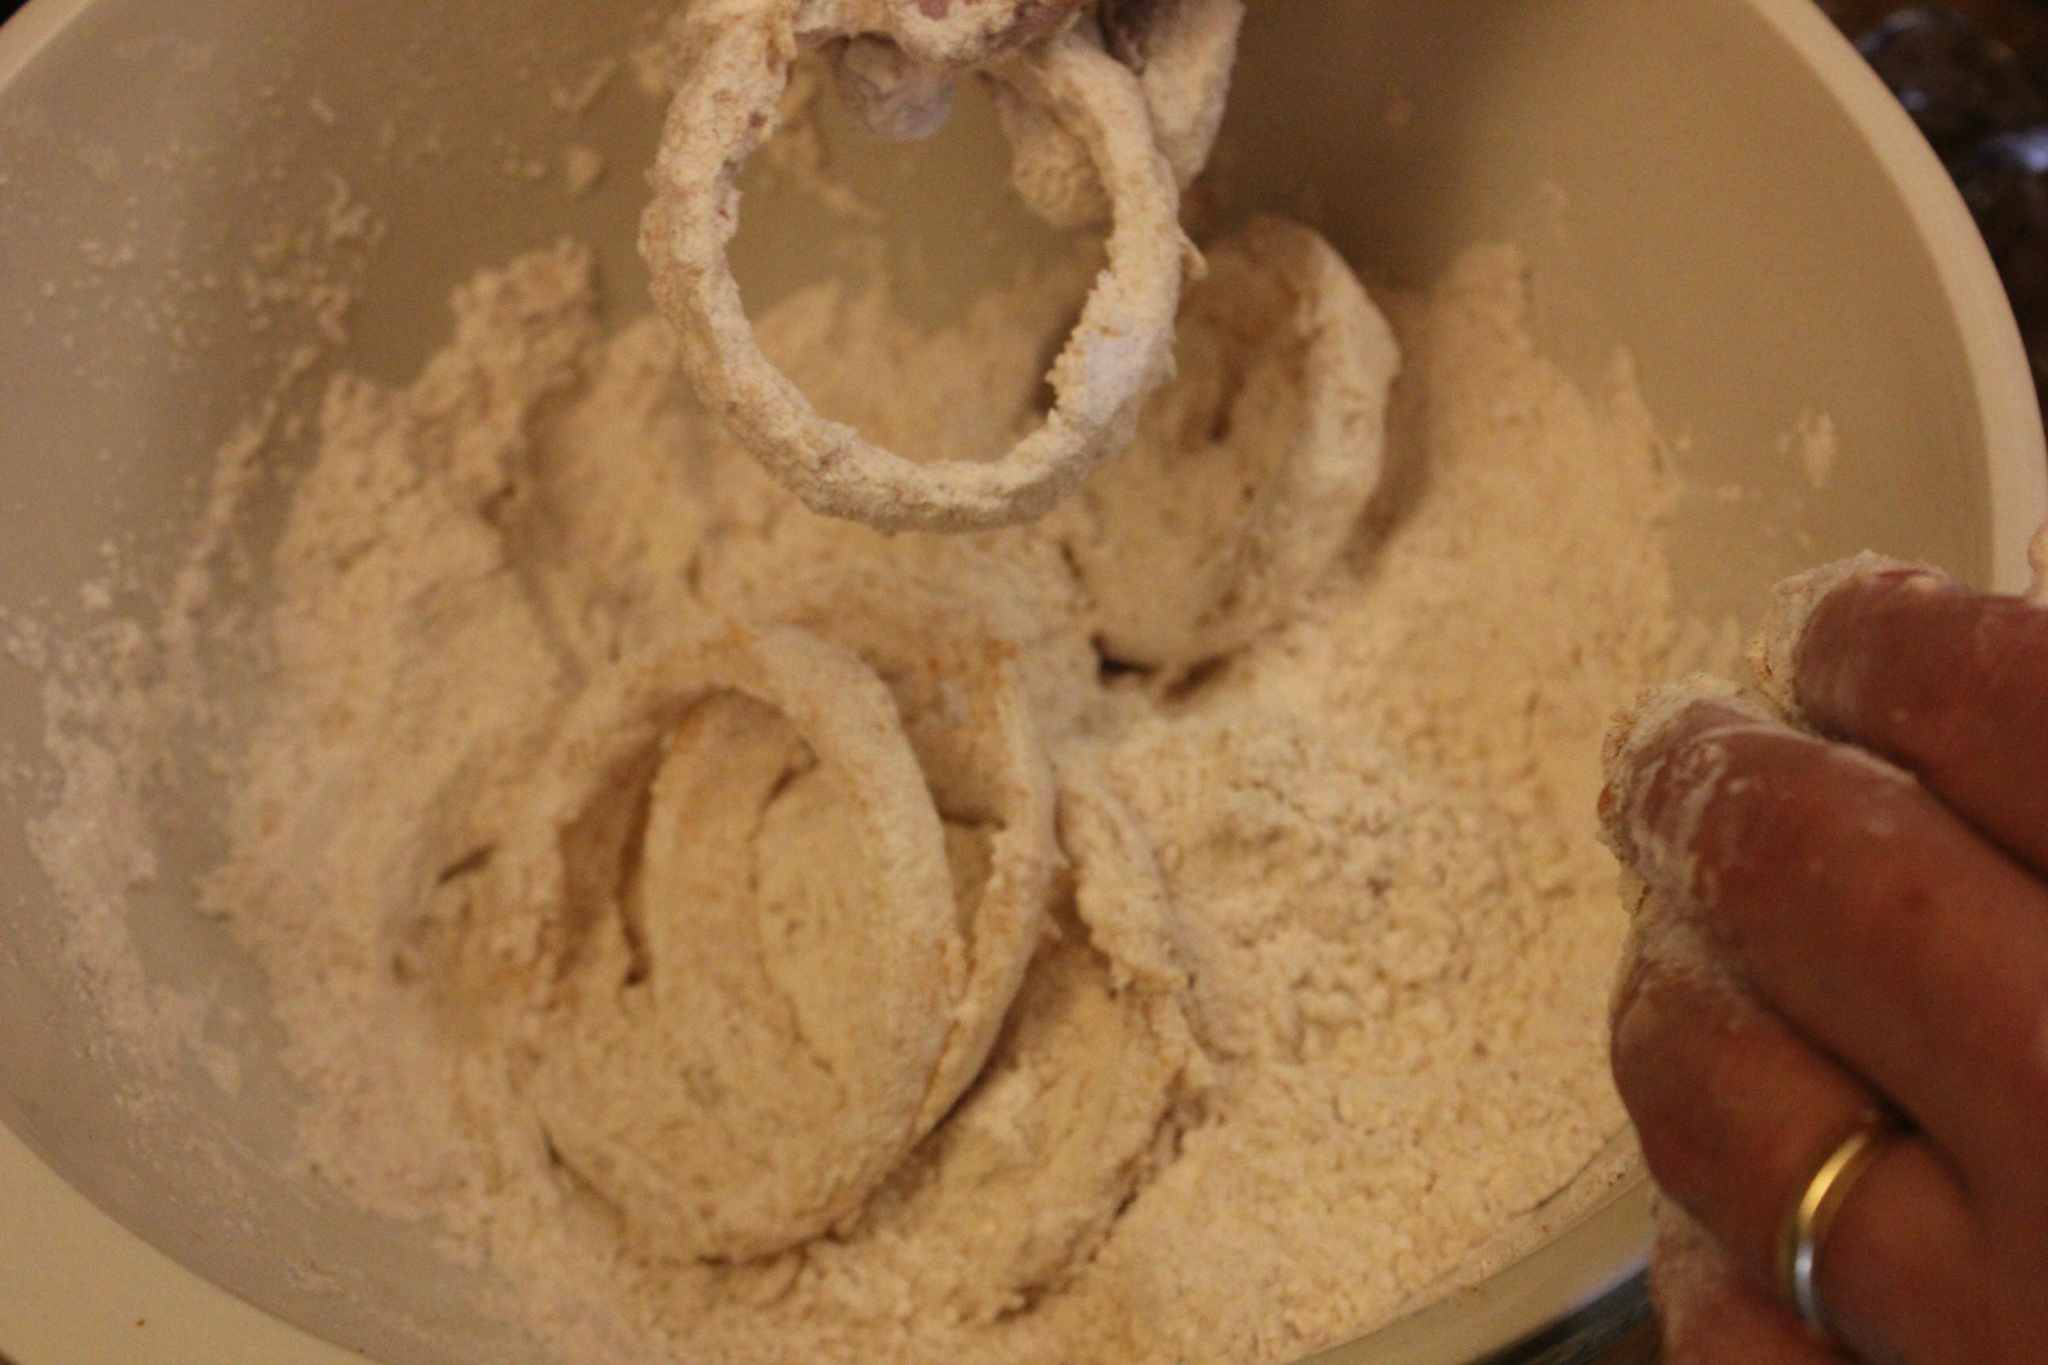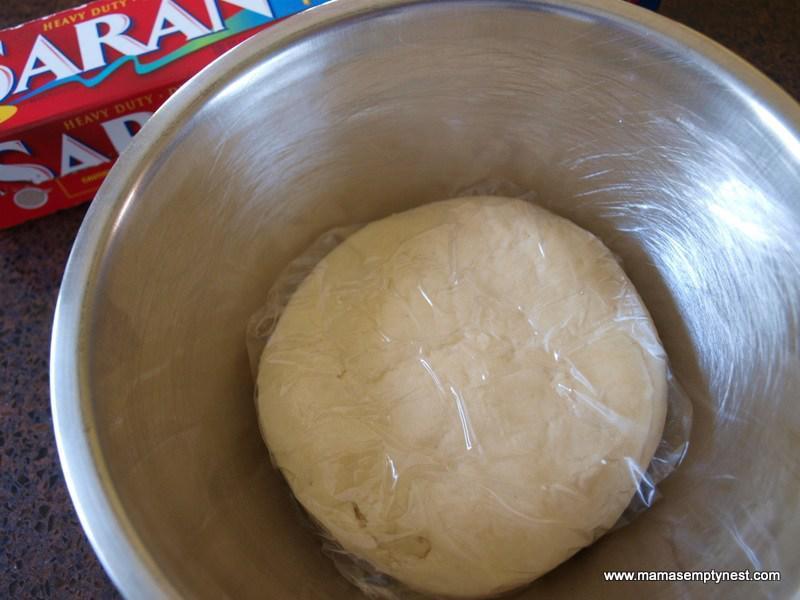The first image is the image on the left, the second image is the image on the right. For the images shown, is this caption "A person is lifting dough." true? Answer yes or no. No. The first image is the image on the left, the second image is the image on the right. Given the left and right images, does the statement "In at least one image a person's hand has wet dough stretching down." hold true? Answer yes or no. No. 